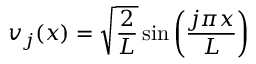Convert formula to latex. <formula><loc_0><loc_0><loc_500><loc_500>v _ { j } ( x ) = { \sqrt { \frac { 2 } { L } } } \sin \left ( { \frac { j \pi x } { L } } \right )</formula> 